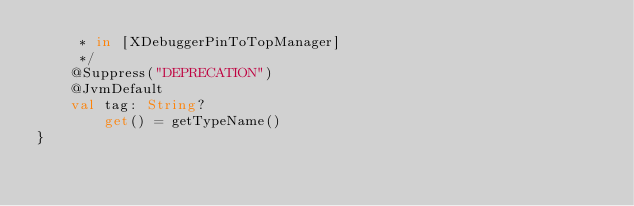<code> <loc_0><loc_0><loc_500><loc_500><_Kotlin_>     * in [XDebuggerPinToTopManager]
     */
    @Suppress("DEPRECATION")
    @JvmDefault
    val tag: String?
        get() = getTypeName()
}</code> 